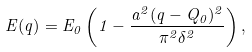Convert formula to latex. <formula><loc_0><loc_0><loc_500><loc_500>E ( { q } ) = E _ { 0 } \left ( 1 - \frac { a ^ { 2 } ( { q } - { Q } _ { 0 } ) ^ { 2 } } { \pi ^ { 2 } \delta ^ { 2 } } \right ) ,</formula> 